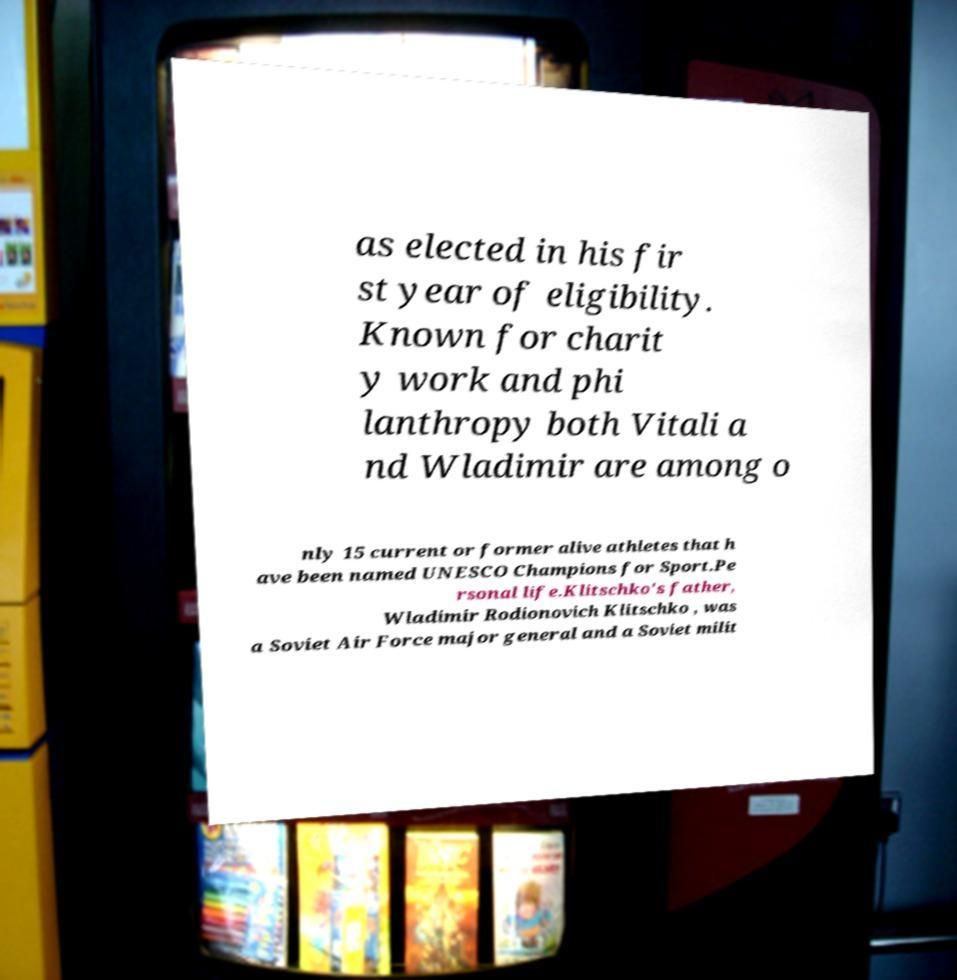Please identify and transcribe the text found in this image. as elected in his fir st year of eligibility. Known for charit y work and phi lanthropy both Vitali a nd Wladimir are among o nly 15 current or former alive athletes that h ave been named UNESCO Champions for Sport.Pe rsonal life.Klitschko's father, Wladimir Rodionovich Klitschko , was a Soviet Air Force major general and a Soviet milit 